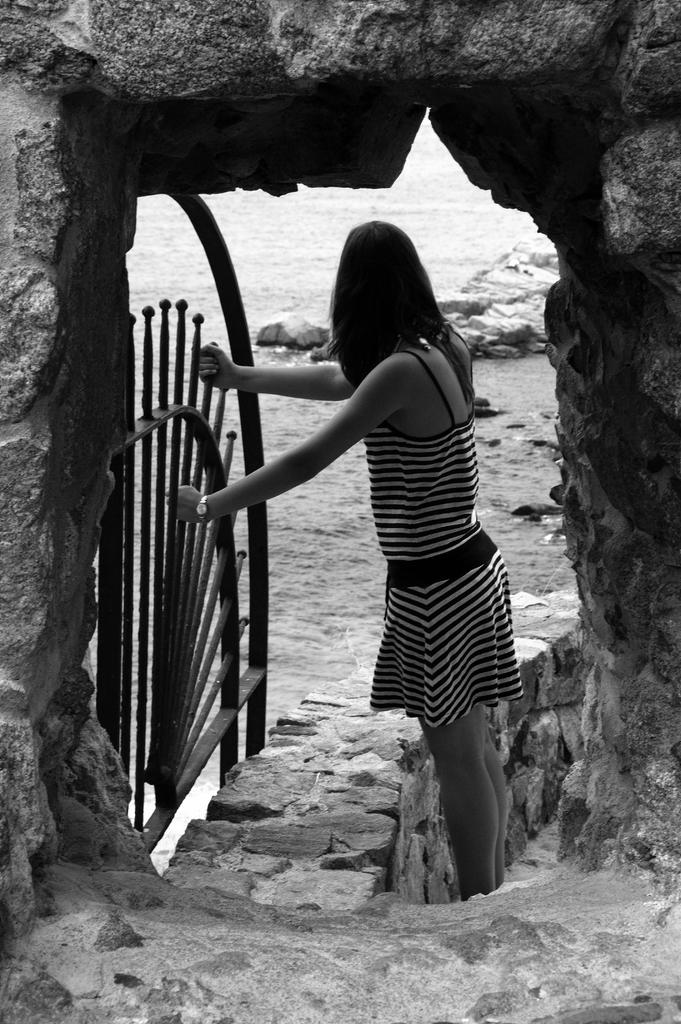What is the color scheme of the image? The image is black and white. Who is present in the image? There is a woman in the image. What is the woman holding in the image? The woman is holding an object. What type of structure can be seen in the image? There is a wall and an arch in the image. What natural element is visible in the image? There is water visible in the image. What type of terrain is present in the image? There are rocks in the image. What type of nut is being used to cream the woman's hair in the image? There is no nut or hair creaming activity present in the image. 